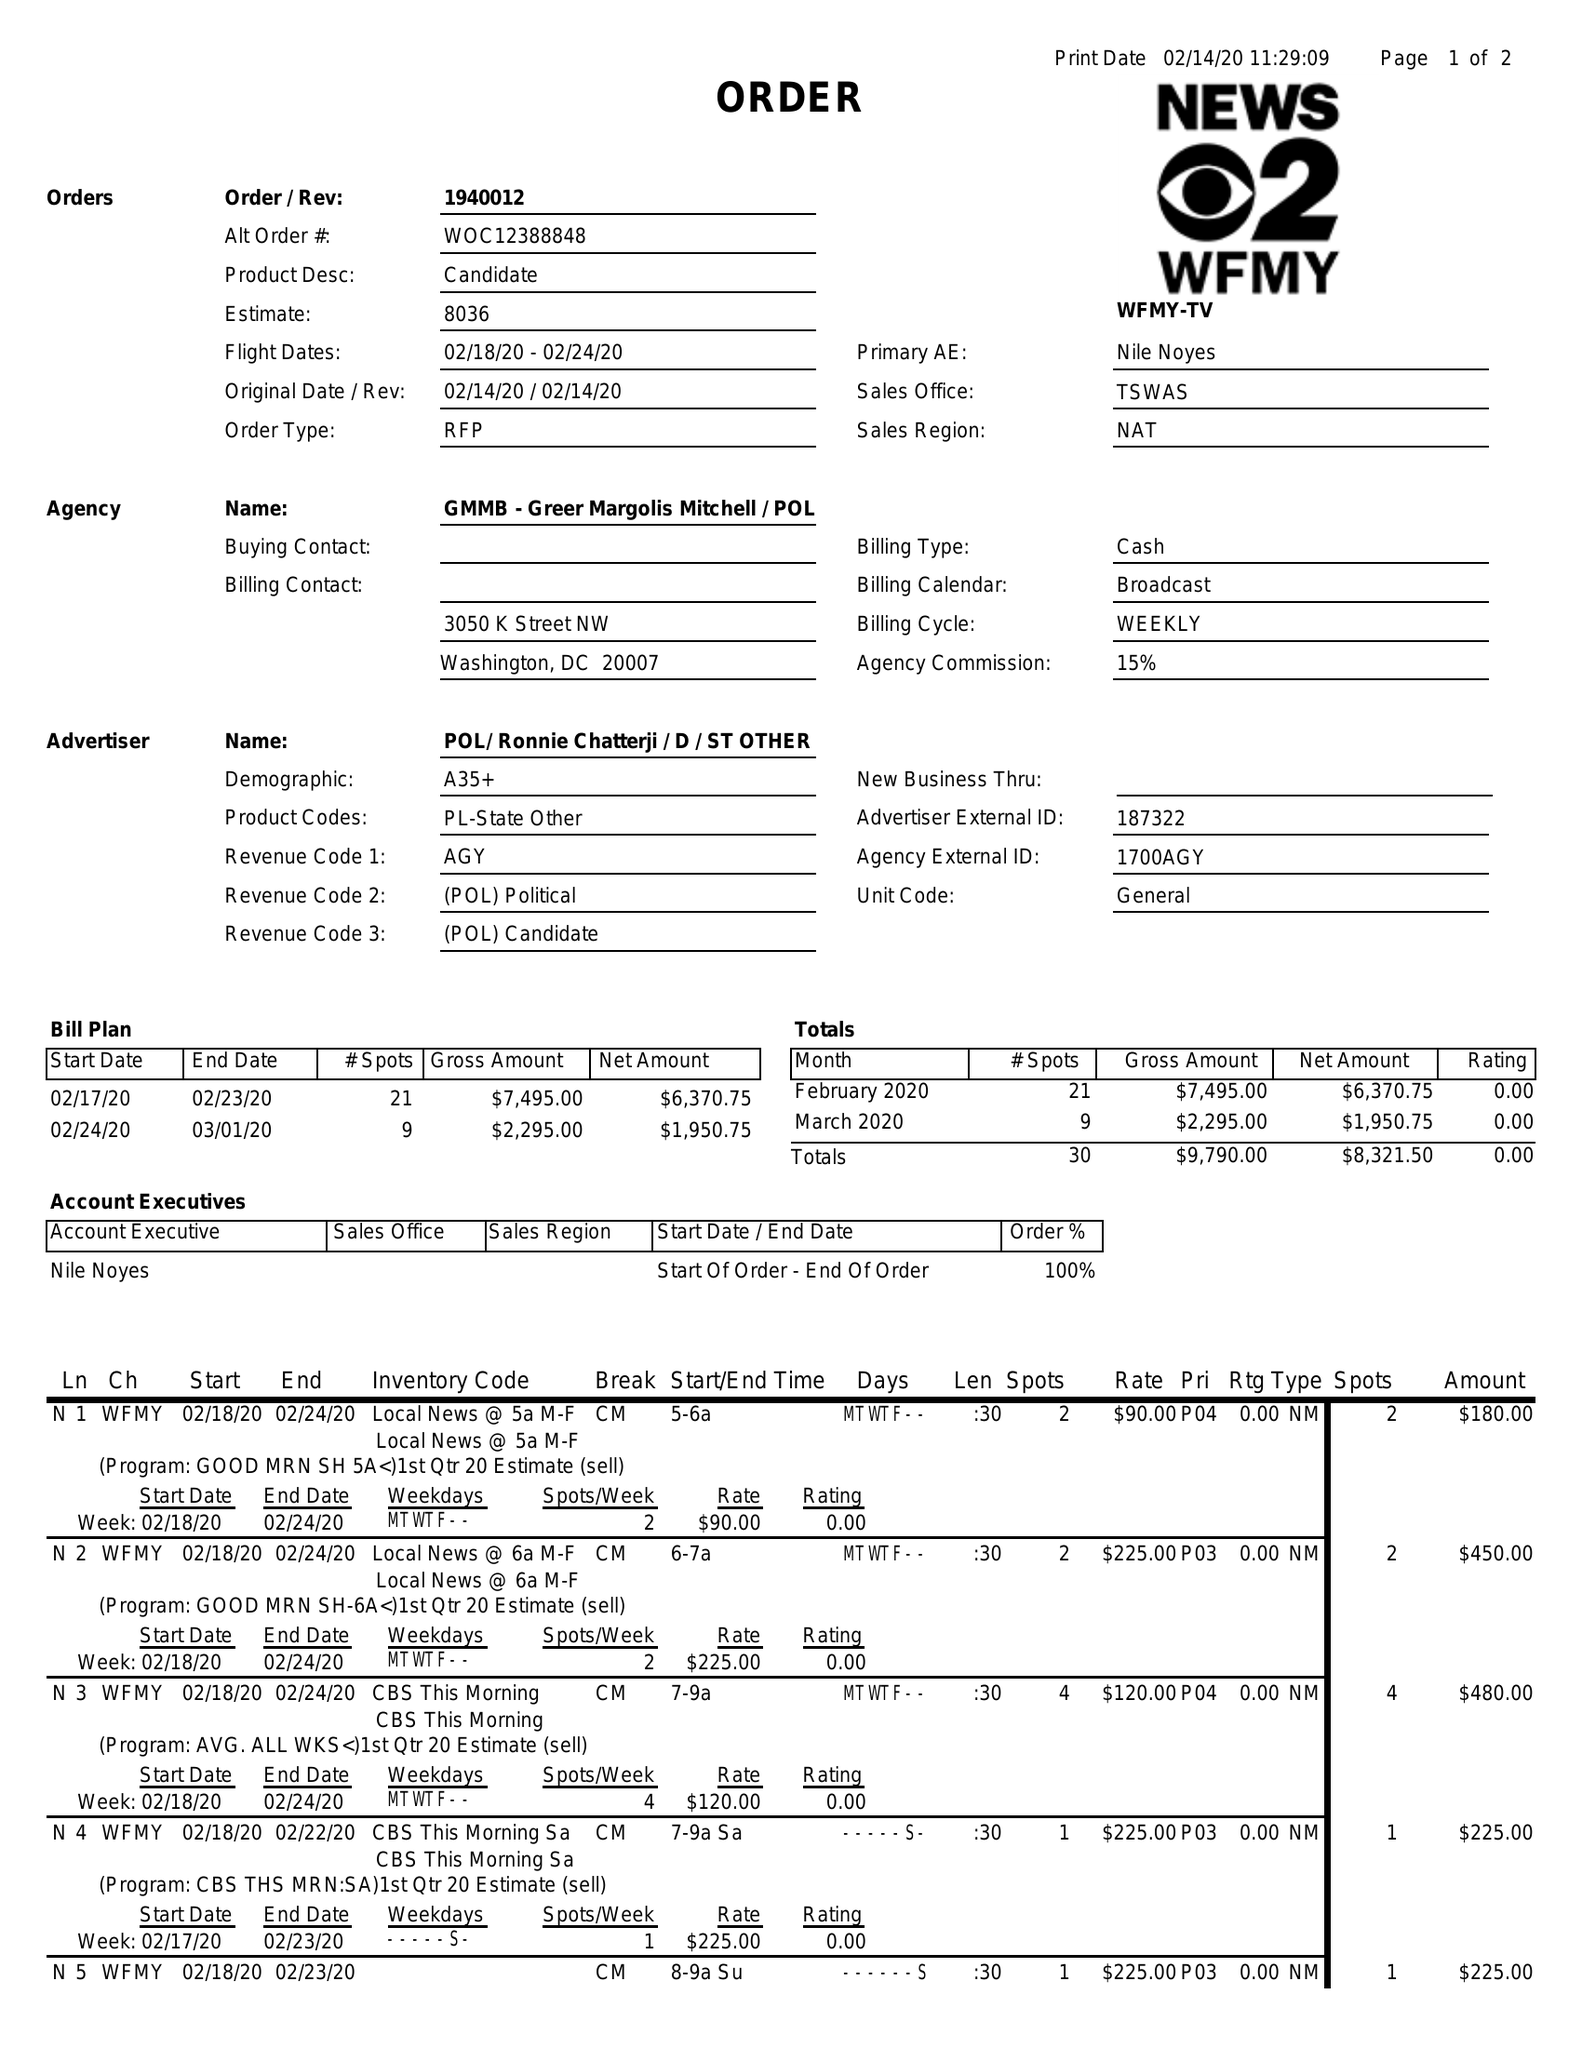What is the value for the gross_amount?
Answer the question using a single word or phrase. 9790.00 